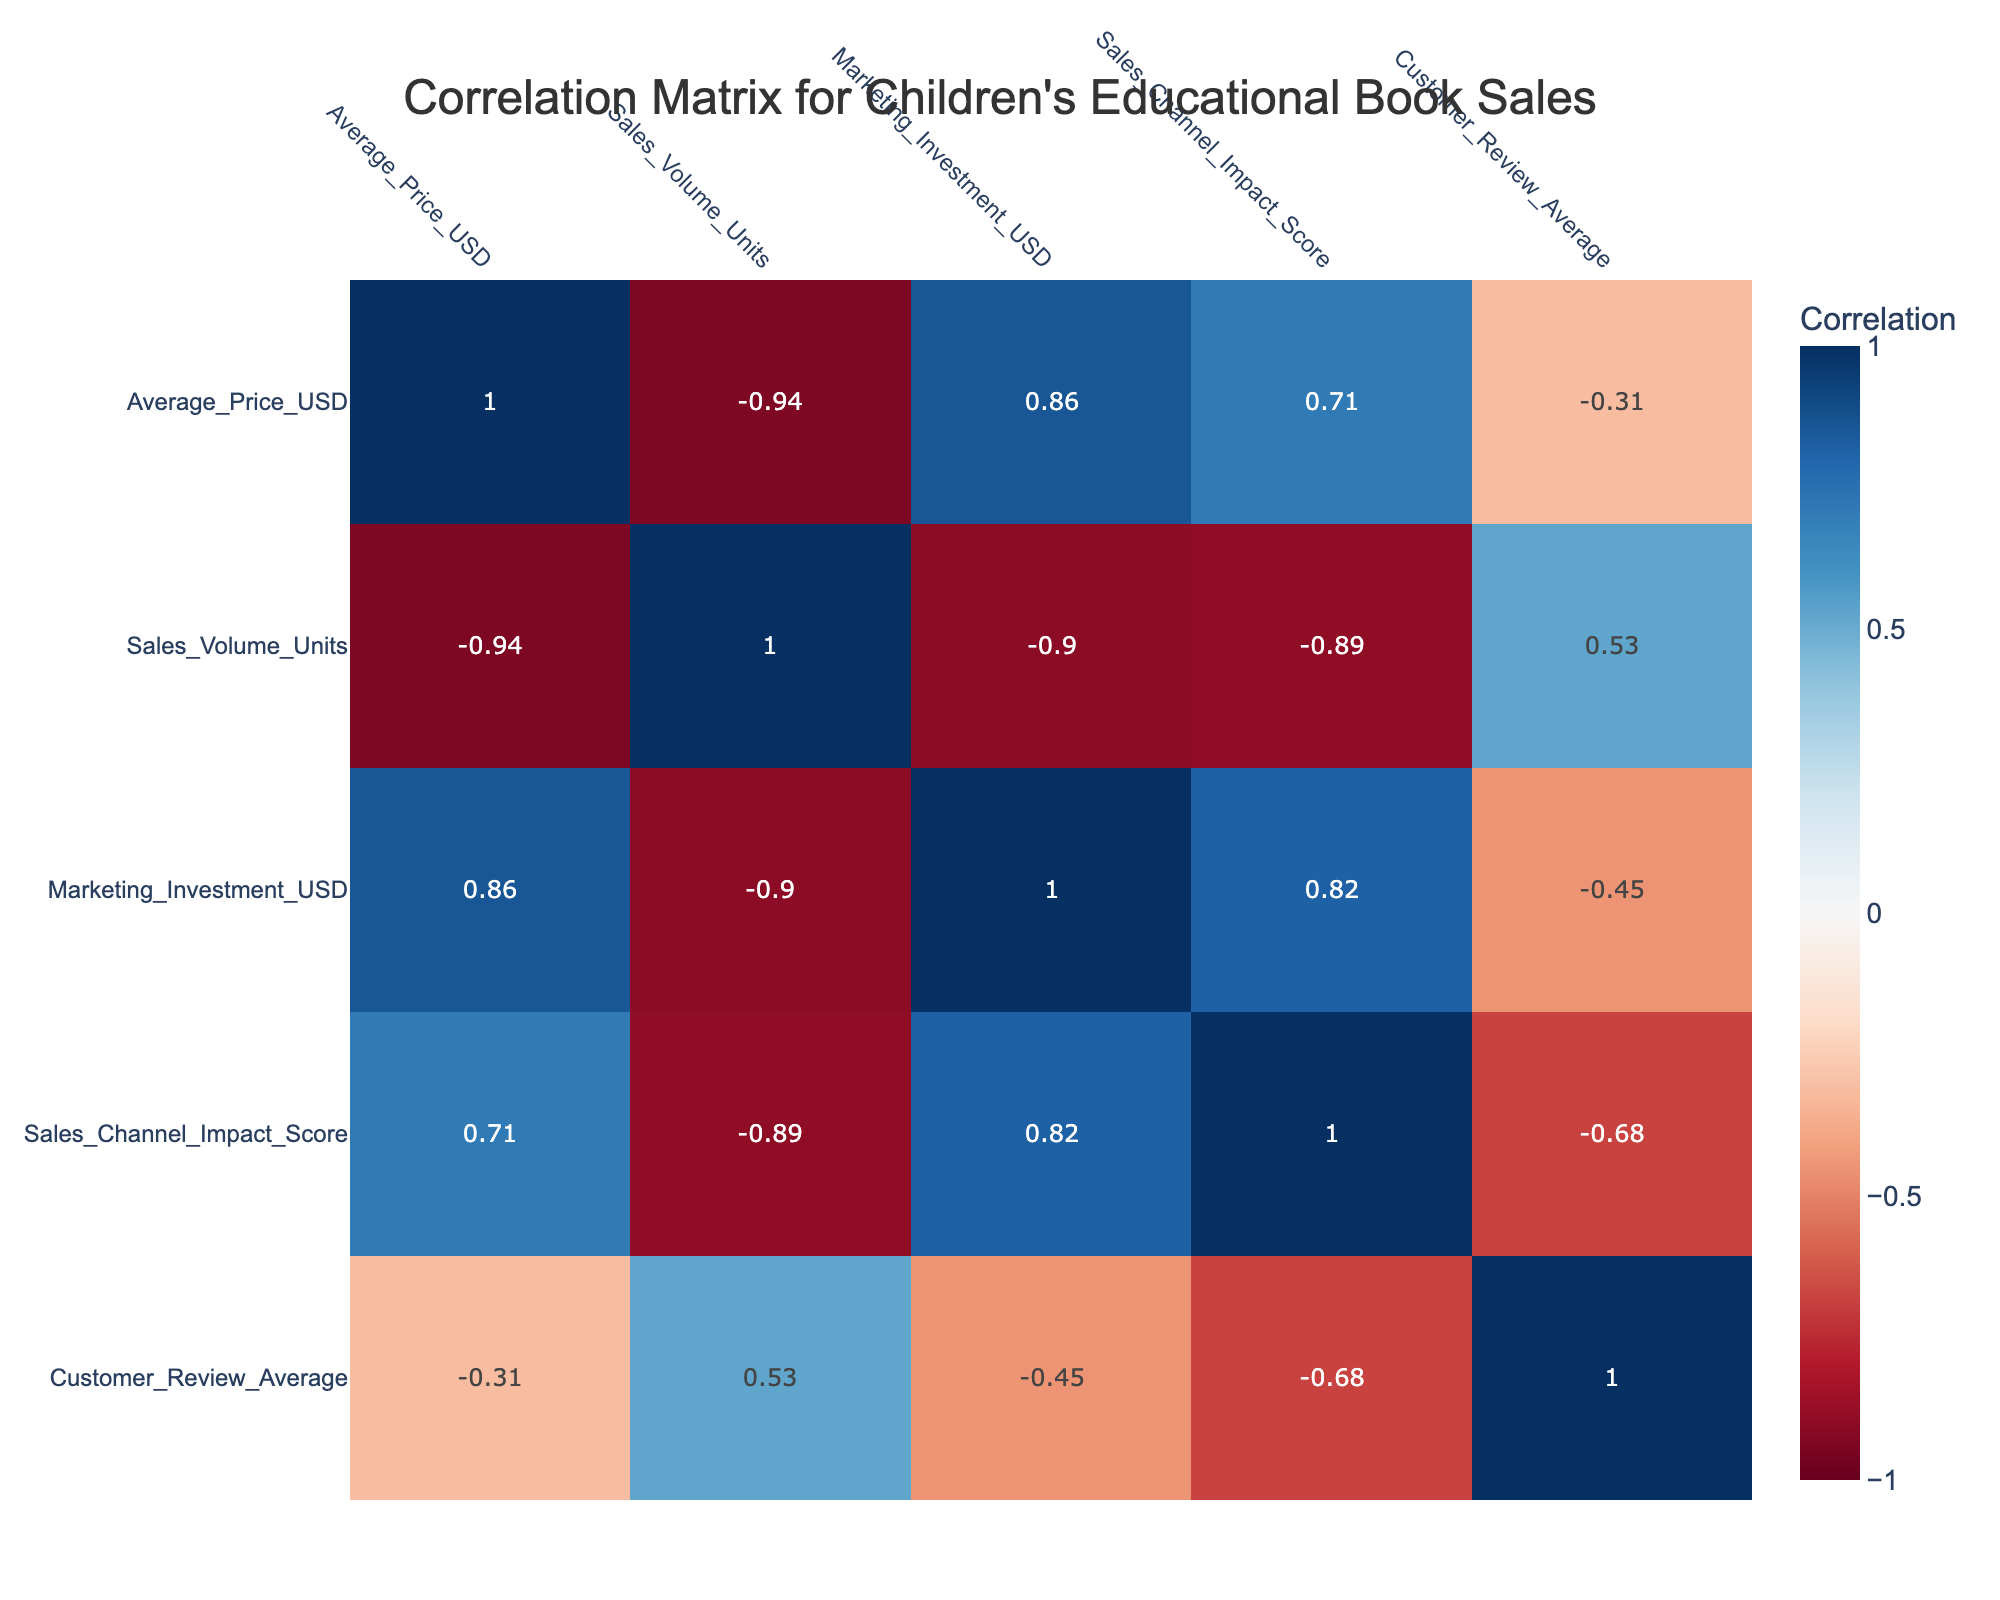What is the highest sales volume achieved for a book pricing strategy? The sales volume for the Freemium Model is 5000 units, which is the highest among all pricing strategies listed in the table.
Answer: 5000 What is the average price of books under Value Pricing? The Average Price under Value Pricing is 9.99 USD as stated in the corresponding row of the table.
Answer: 9.99 USD Is the Sales Channel Impact Score for Premium Pricing greater than 8? The Sales Channel Impact Score for Premium Pricing is 9, which is indeed greater than 8.
Answer: Yes What is the total sales volume for Bundle Pricing and Discount Pricing combined? The sales volume for Bundle Pricing is 1200 units and for Discount Pricing is 3000 units. Together, they total 1200 + 3000 = 4200 units.
Answer: 4200 What is the correlation between Average Price and Sales Volume? By referring to the correlation matrix, the correlation value between Average Price and Sales Volume is -0.67, indicating a negative correlation.
Answer: -0.67 Which pricing strategy has the highest average customer review score? The Freemium Model has the highest average customer review score of 4.9.
Answer: 4.9 What is the difference in sales volume between Discount Pricing and Bundle Pricing? The sales volume for Discount Pricing is 3000 units, while for Bundle Pricing it is 1200 units. The difference is 3000 - 1200 = 1800 units.
Answer: 1800 What could be inferred if the Marketing Investment USD increases? Generally, higher marketing investments often lead to higher sales volumes, as observed in the table, where strategies with higher investments like Premium Pricing and Bundle Pricing correlate with lower sales volumes due to pricing levels.
Answer: Higher sales expected What pricing strategy has the lowest average price? The Discount Pricing strategy has the lowest average price of 7.99 USD, as observed in the table.
Answer: 7.99 USD 